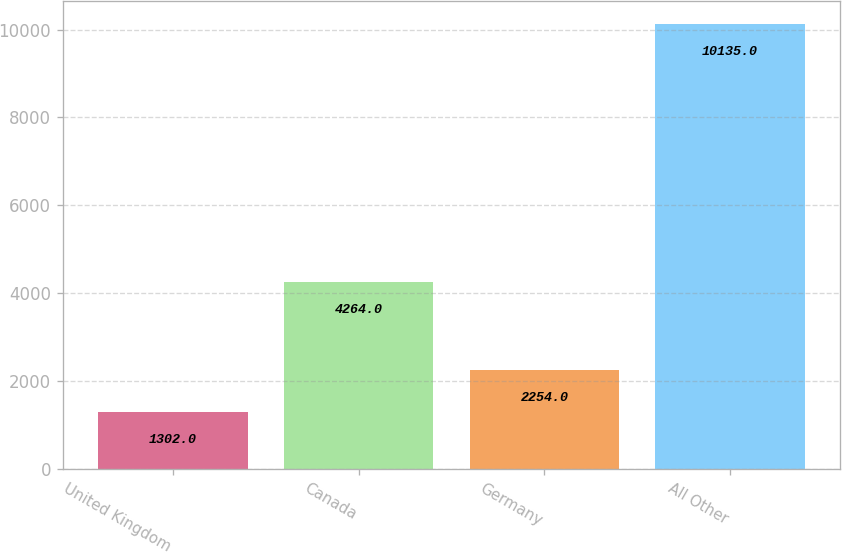Convert chart to OTSL. <chart><loc_0><loc_0><loc_500><loc_500><bar_chart><fcel>United Kingdom<fcel>Canada<fcel>Germany<fcel>All Other<nl><fcel>1302<fcel>4264<fcel>2254<fcel>10135<nl></chart> 